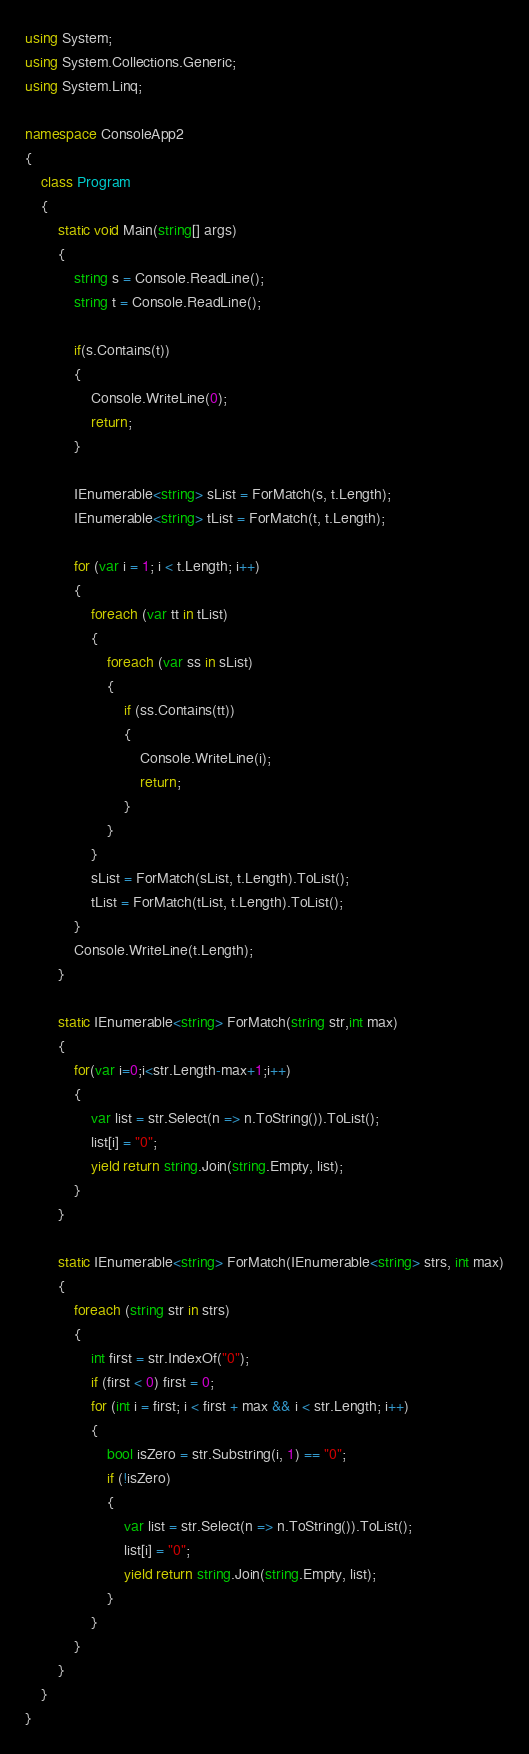<code> <loc_0><loc_0><loc_500><loc_500><_C#_>using System;
using System.Collections.Generic;
using System.Linq;

namespace ConsoleApp2
{
    class Program
    {
        static void Main(string[] args)
        {
            string s = Console.ReadLine();
            string t = Console.ReadLine();

            if(s.Contains(t))
            {
                Console.WriteLine(0);
                return;
            }

            IEnumerable<string> sList = ForMatch(s, t.Length);
            IEnumerable<string> tList = ForMatch(t, t.Length);

            for (var i = 1; i < t.Length; i++)
            {
                foreach (var tt in tList)
                {
                    foreach (var ss in sList)
                    {
                        if (ss.Contains(tt))
                        {
                            Console.WriteLine(i);
                            return;
                        }
                    }
                }
                sList = ForMatch(sList, t.Length).ToList();
                tList = ForMatch(tList, t.Length).ToList();
            }
            Console.WriteLine(t.Length);
        }

        static IEnumerable<string> ForMatch(string str,int max)
        {
            for(var i=0;i<str.Length-max+1;i++)
            {
                var list = str.Select(n => n.ToString()).ToList();
                list[i] = "0";
                yield return string.Join(string.Empty, list);
            }
        }

        static IEnumerable<string> ForMatch(IEnumerable<string> strs, int max)
        {
            foreach (string str in strs)
            {
                int first = str.IndexOf("0");
                if (first < 0) first = 0;
                for (int i = first; i < first + max && i < str.Length; i++)
                {
                    bool isZero = str.Substring(i, 1) == "0";
                    if (!isZero)
                    {
                        var list = str.Select(n => n.ToString()).ToList();
                        list[i] = "0";
                        yield return string.Join(string.Empty, list);
                    }
                }
            }
        }
    }
}</code> 